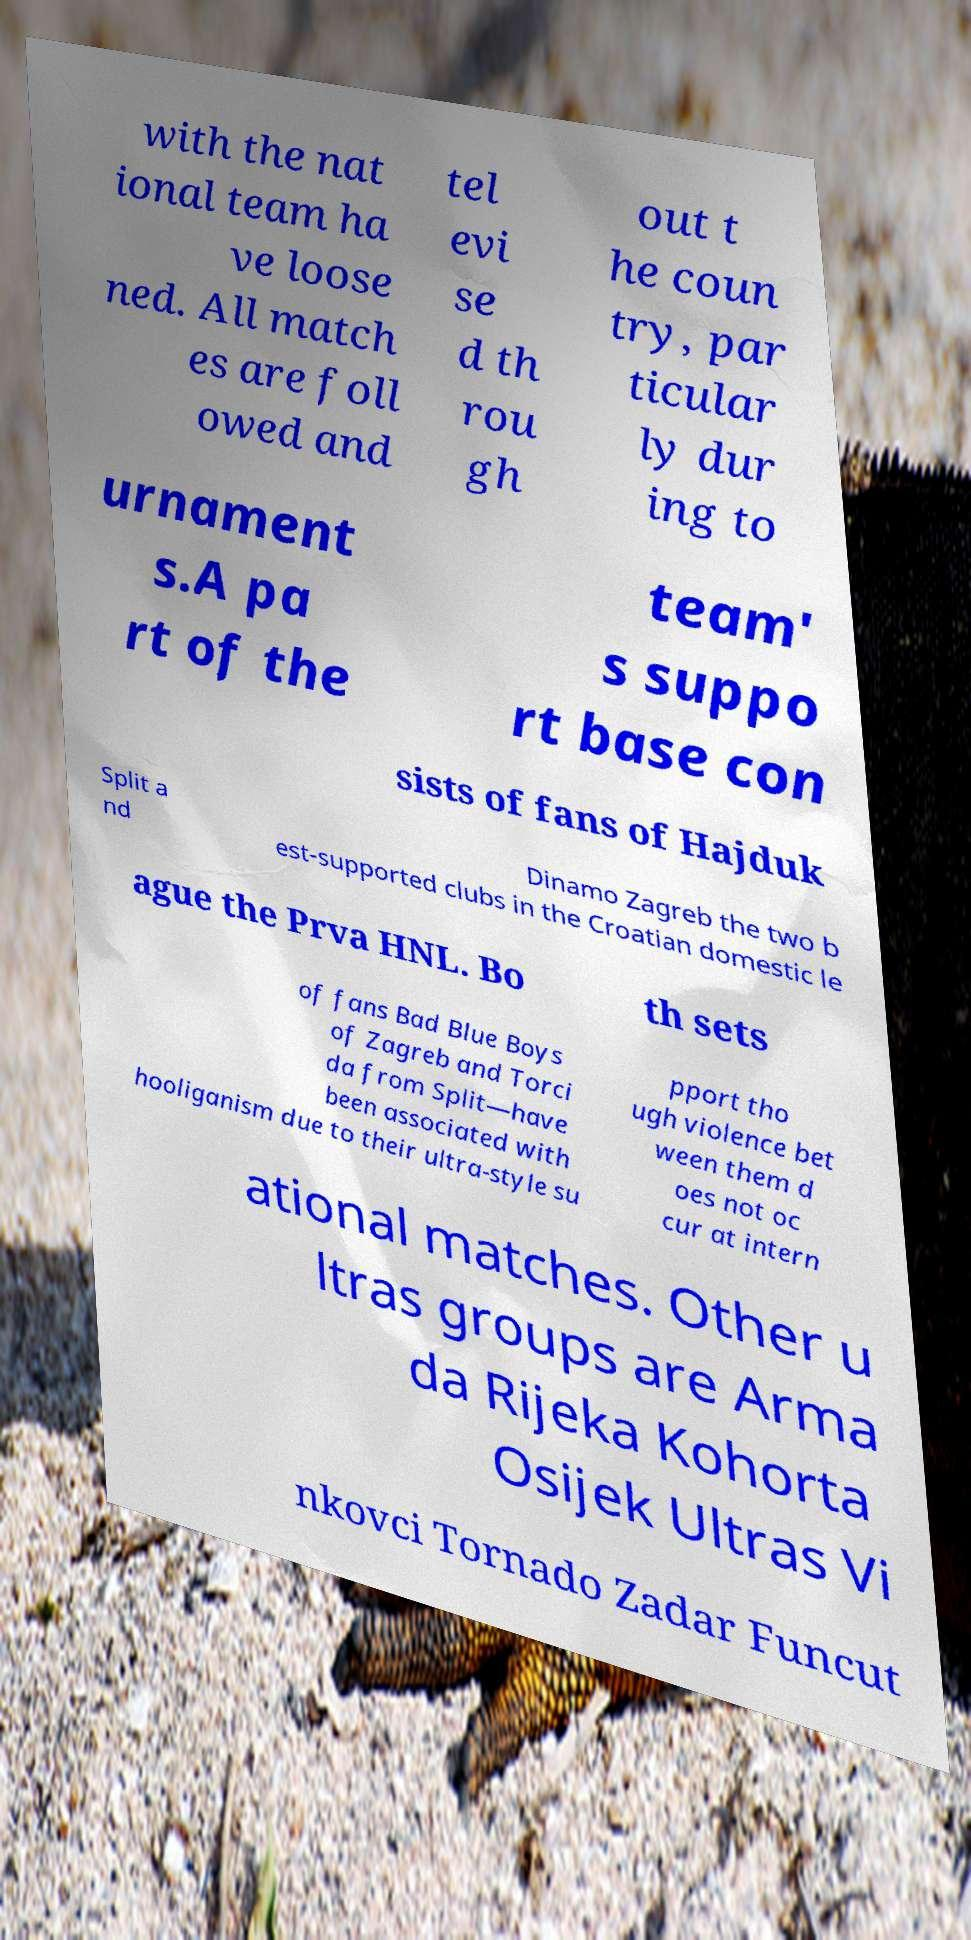There's text embedded in this image that I need extracted. Can you transcribe it verbatim? with the nat ional team ha ve loose ned. All match es are foll owed and tel evi se d th rou gh out t he coun try, par ticular ly dur ing to urnament s.A pa rt of the team' s suppo rt base con sists of fans of Hajduk Split a nd Dinamo Zagreb the two b est-supported clubs in the Croatian domestic le ague the Prva HNL. Bo th sets of fans Bad Blue Boys of Zagreb and Torci da from Split—have been associated with hooliganism due to their ultra-style su pport tho ugh violence bet ween them d oes not oc cur at intern ational matches. Other u ltras groups are Arma da Rijeka Kohorta Osijek Ultras Vi nkovci Tornado Zadar Funcut 